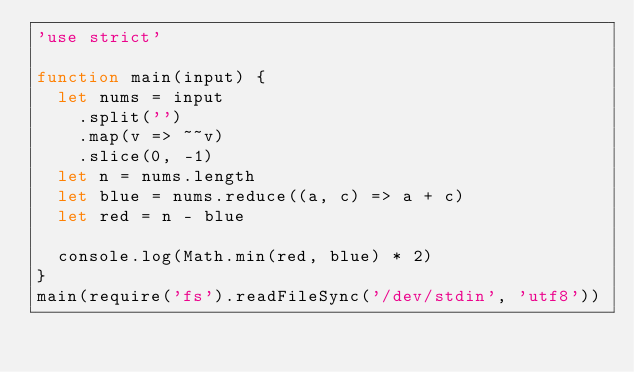<code> <loc_0><loc_0><loc_500><loc_500><_JavaScript_>'use strict'

function main(input) {
  let nums = input
    .split('')
    .map(v => ~~v)
    .slice(0, -1)
  let n = nums.length
  let blue = nums.reduce((a, c) => a + c)
  let red = n - blue

  console.log(Math.min(red, blue) * 2)
}
main(require('fs').readFileSync('/dev/stdin', 'utf8'))
</code> 